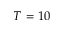<formula> <loc_0><loc_0><loc_500><loc_500>T = 1 0</formula> 